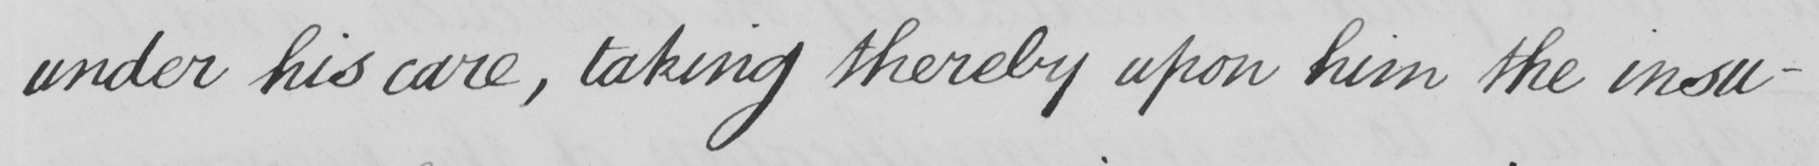What is written in this line of handwriting? under his care , taking thereby upon him the insu- 